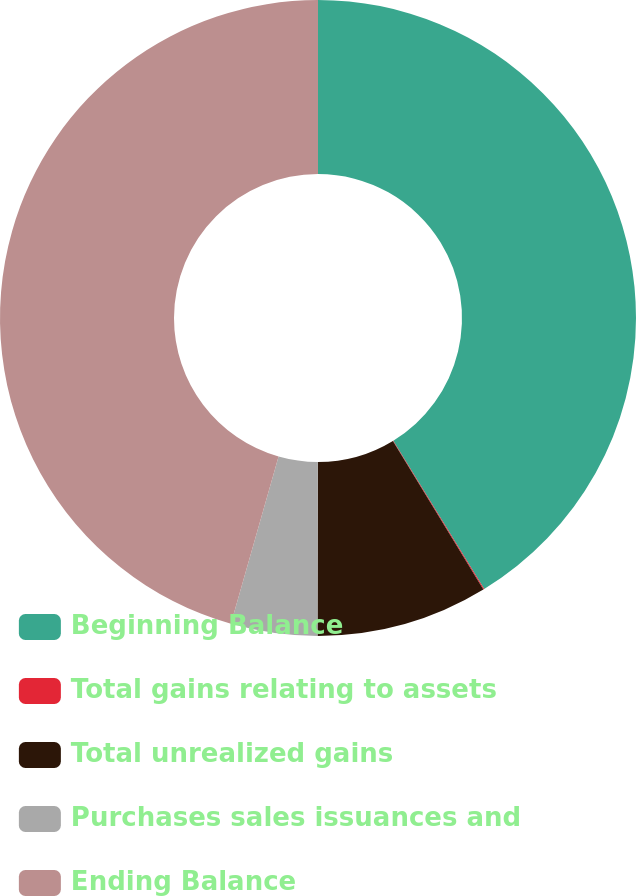Convert chart to OTSL. <chart><loc_0><loc_0><loc_500><loc_500><pie_chart><fcel>Beginning Balance<fcel>Total gains relating to assets<fcel>Total unrealized gains<fcel>Purchases sales issuances and<fcel>Ending Balance<nl><fcel>41.25%<fcel>0.05%<fcel>8.73%<fcel>4.39%<fcel>45.59%<nl></chart> 